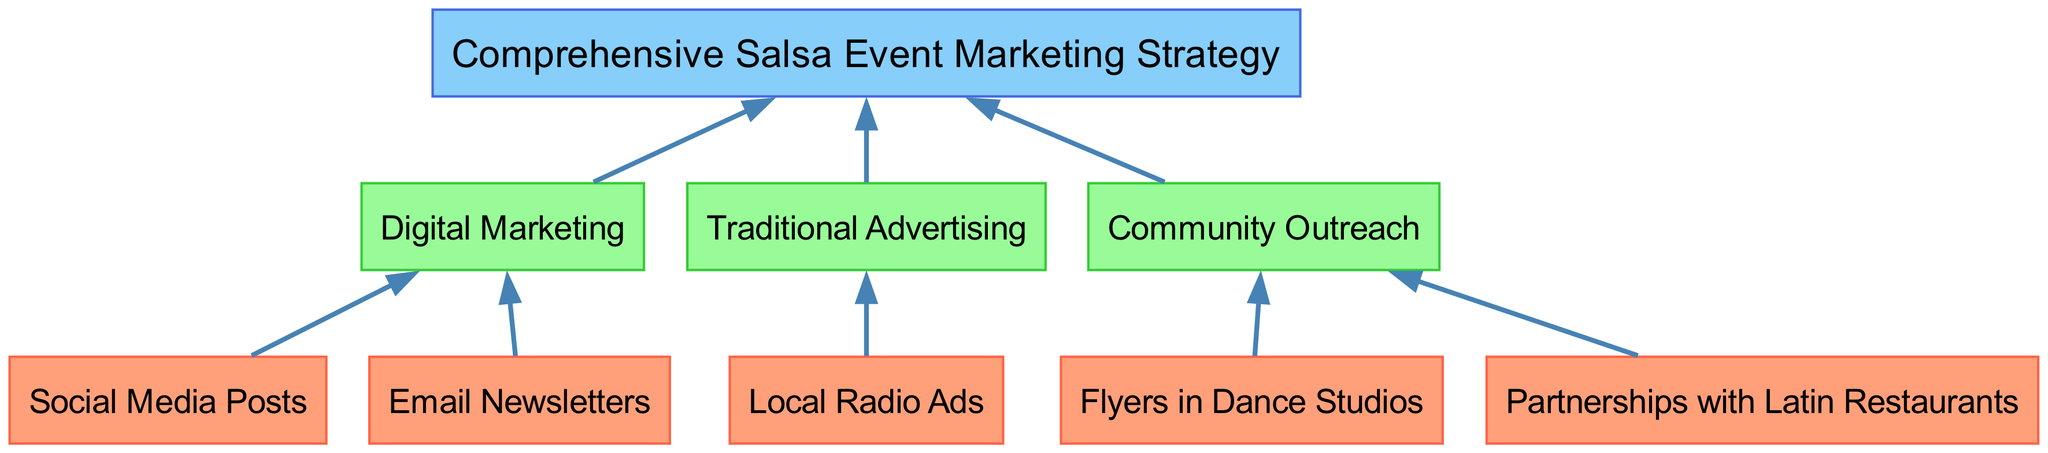What are the bottom elements of the diagram? The bottom elements are listed directly in the diagram, representing the various marketing strategies used at the grassroots level. They are: Social Media Posts, Email Newsletters, Local Radio Ads, Flyers in Dance Studios, and Partnerships with Latin Restaurants.
Answer: Social Media Posts, Email Newsletters, Local Radio Ads, Flyers in Dance Studios, Partnerships with Latin Restaurants How many middle elements are there? Counting the middle elements shown in the diagram reveals three distinct elements: Digital Marketing, Traditional Advertising, and Community Outreach. Therefore, the total is three.
Answer: 3 Which advertising method is linked to Traditional Advertising? The diagram clearly shows that Local Radio Ads are the method connected to Traditional Advertising, establishing a direct relationship in the flow chart.
Answer: Local Radio Ads What is the top element of the diagram? The top element is indicated at the highest point of the diagram, summarizing the entire marketing approach. That element is the "Comprehensive Salsa Event Marketing Strategy."
Answer: Comprehensive Salsa Event Marketing Strategy Which bottom elements are connected to Community Outreach? Two bottom elements are shown as being linked to Community Outreach: Flyers in Dance Studios and Partnerships with Latin Restaurants. This shows the community-focused strategies utilized.
Answer: Flyers in Dance Studios, Partnerships with Latin Restaurants What are the relationships between Digital Marketing and the top element? The diagram outlines two connections where Digital Marketing leads to the top element, indicating it as a crucial part of the overall marketing strategy. The connections are established through Social Media Posts and Email Newsletters.
Answer: Social Media Posts, Email Newsletters How many total connections are there in the diagram? By totaling all the lines drawn between nodes in the diagram, you can find that there are eight distinct connections linking the various components together.
Answer: 8 Which element has the most outputs leading to the top strategy? Analyzing the outgoing connections from the elements, it can be determined that Community Outreach leads to the top strategy, having two inputs (Flyers in Dance Studios and Partnerships with Latin Restaurants), making it more influential in that regard.
Answer: Community Outreach 